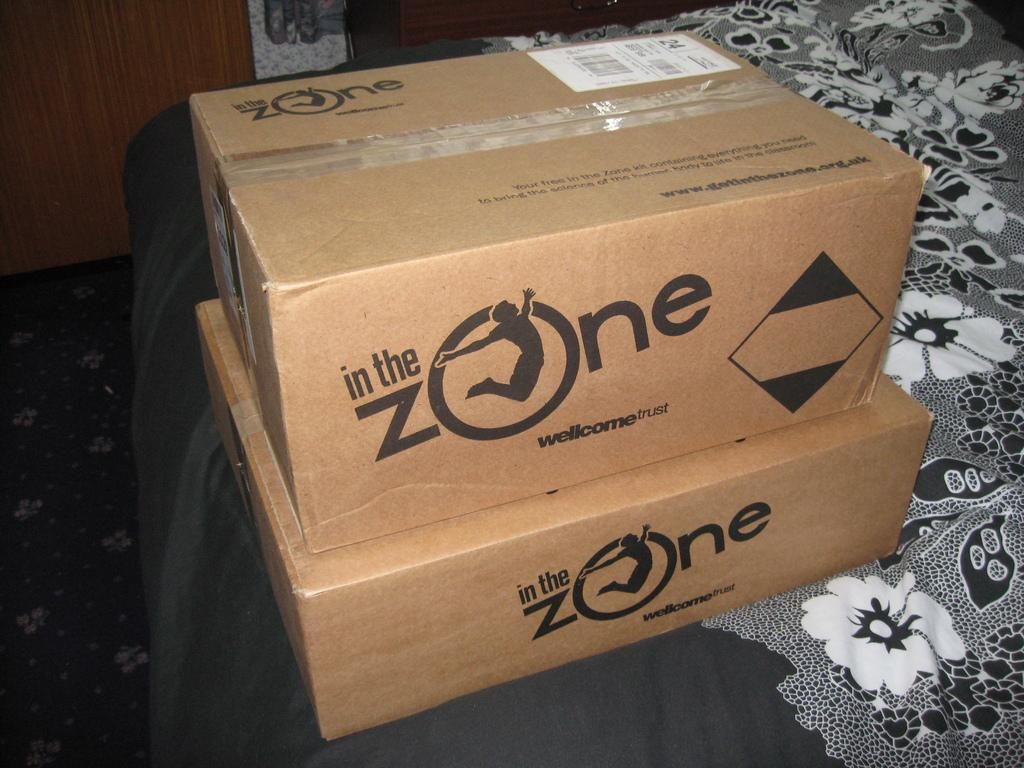<image>
Create a compact narrative representing the image presented. Boxes from In The Zone are stacked on top of each other. 